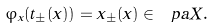<formula> <loc_0><loc_0><loc_500><loc_500>\varphi _ { x } ( t _ { \pm } ( x ) ) = x _ { \pm } ( x ) \in \ p a X .</formula> 